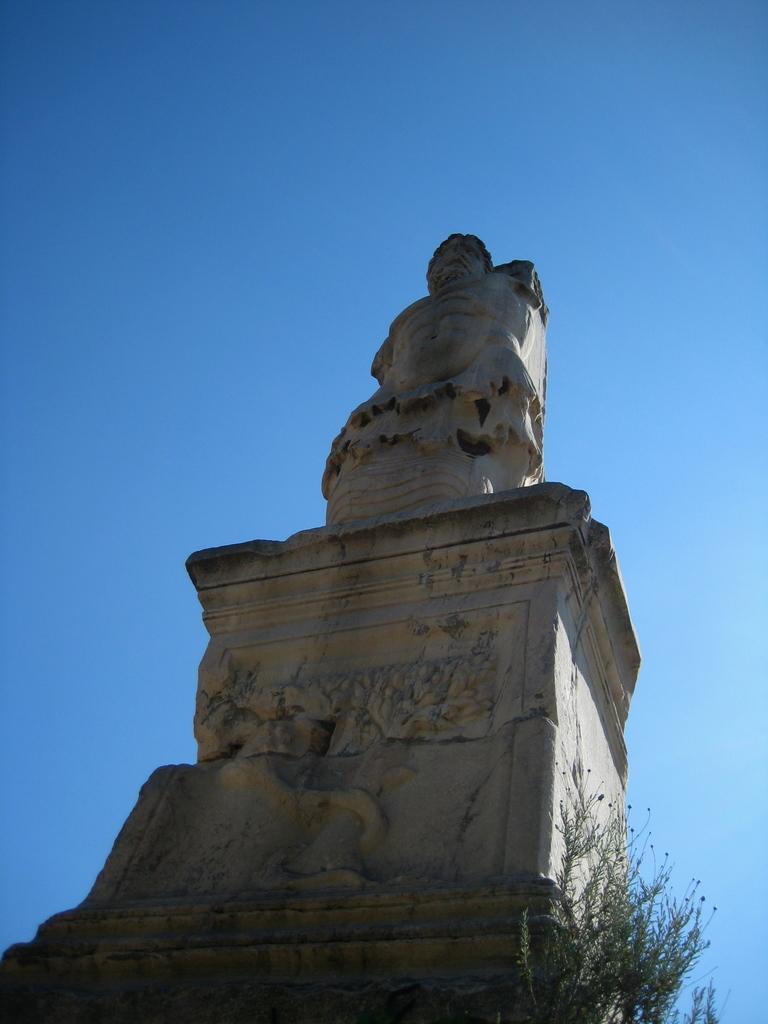How would you summarize this image in a sentence or two? In this picture we can see a statue and on the right side of the statue there are plants and behind the statue there is a sky. 